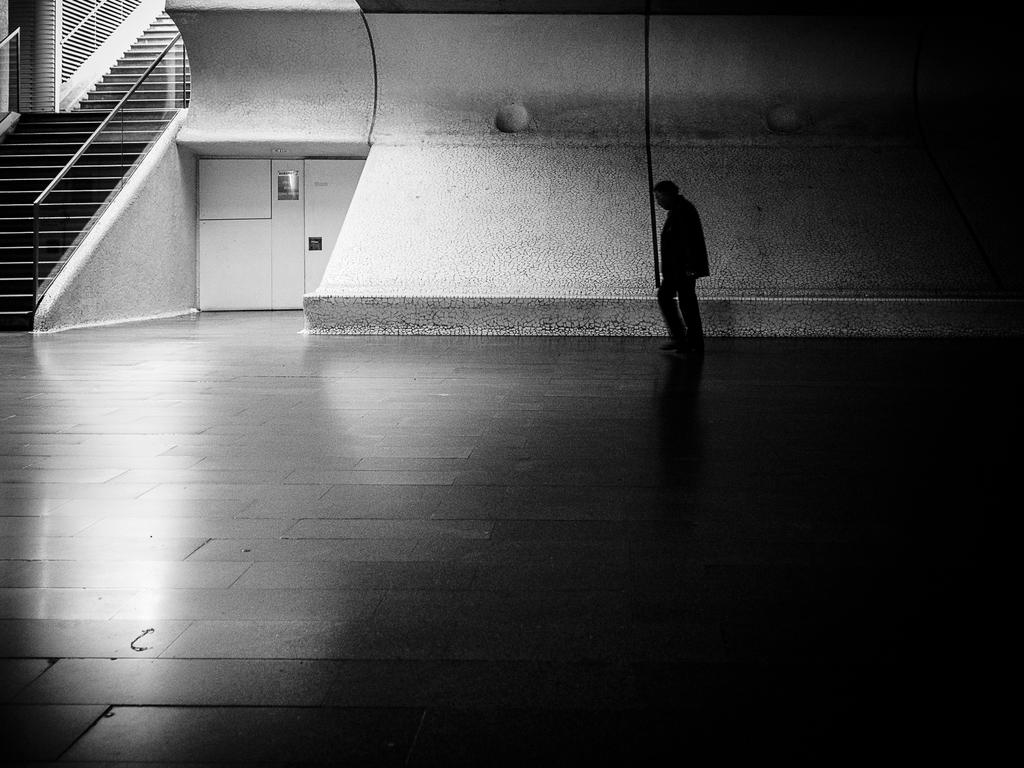What is the person in the image doing? The person is walking in the image. On what surface is the person walking? The person is walking on the floor. What can be seen in the background of the image? There is a wall visible in the image. Are there any architectural features present in the image? Yes, stairs are present in the top left corner of the image. What type of nut is being attacked by the person in the image? There is no nut or attack present in the image; it features a person walking on the floor with a wall and stairs in the background. 